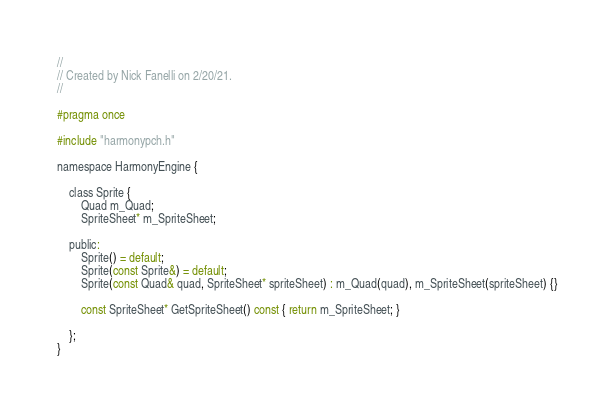Convert code to text. <code><loc_0><loc_0><loc_500><loc_500><_C_>//
// Created by Nick Fanelli on 2/20/21.
//

#pragma once

#include "harmonypch.h"

namespace HarmonyEngine {

    class Sprite {
        Quad m_Quad;
        SpriteSheet* m_SpriteSheet;

    public:
        Sprite() = default;
        Sprite(const Sprite&) = default;
        Sprite(const Quad& quad, SpriteSheet* spriteSheet) : m_Quad(quad), m_SpriteSheet(spriteSheet) {}

    	const SpriteSheet* GetSpriteSheet() const { return m_SpriteSheet; }

    };
}</code> 